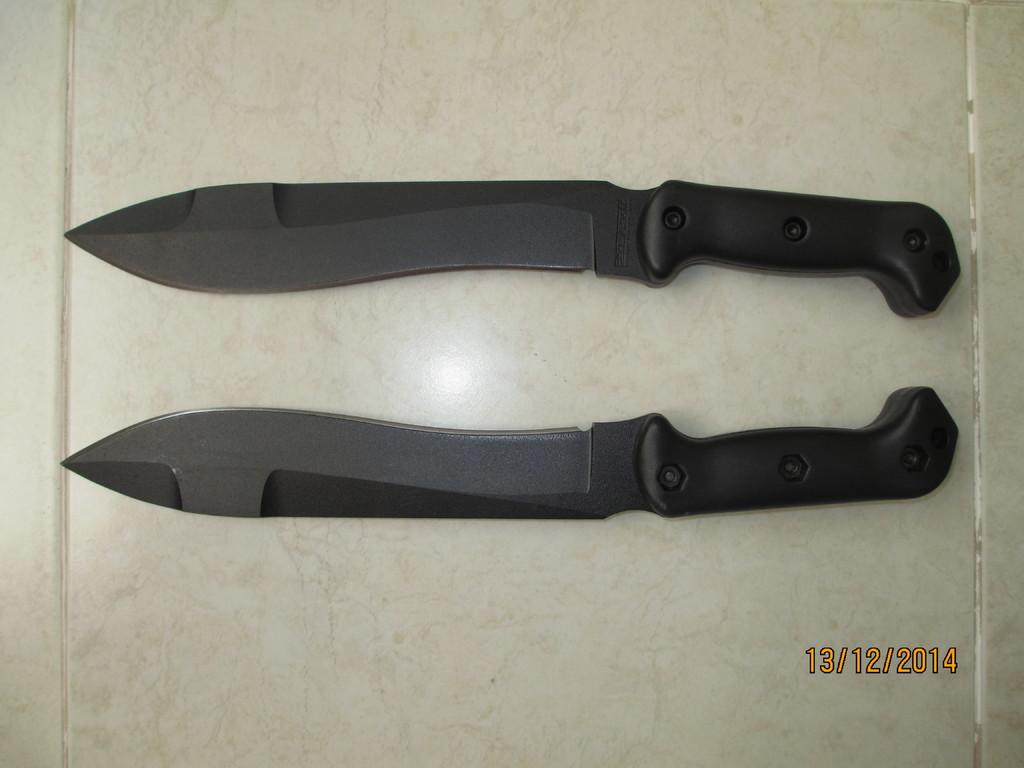What type of utensils are present in the image? There are two black knives in the image. Where are the knives located? The knives are on a table. What type of farm animals can be seen in the image? There are no farm animals present in the image; it only features two black knives on a table. 